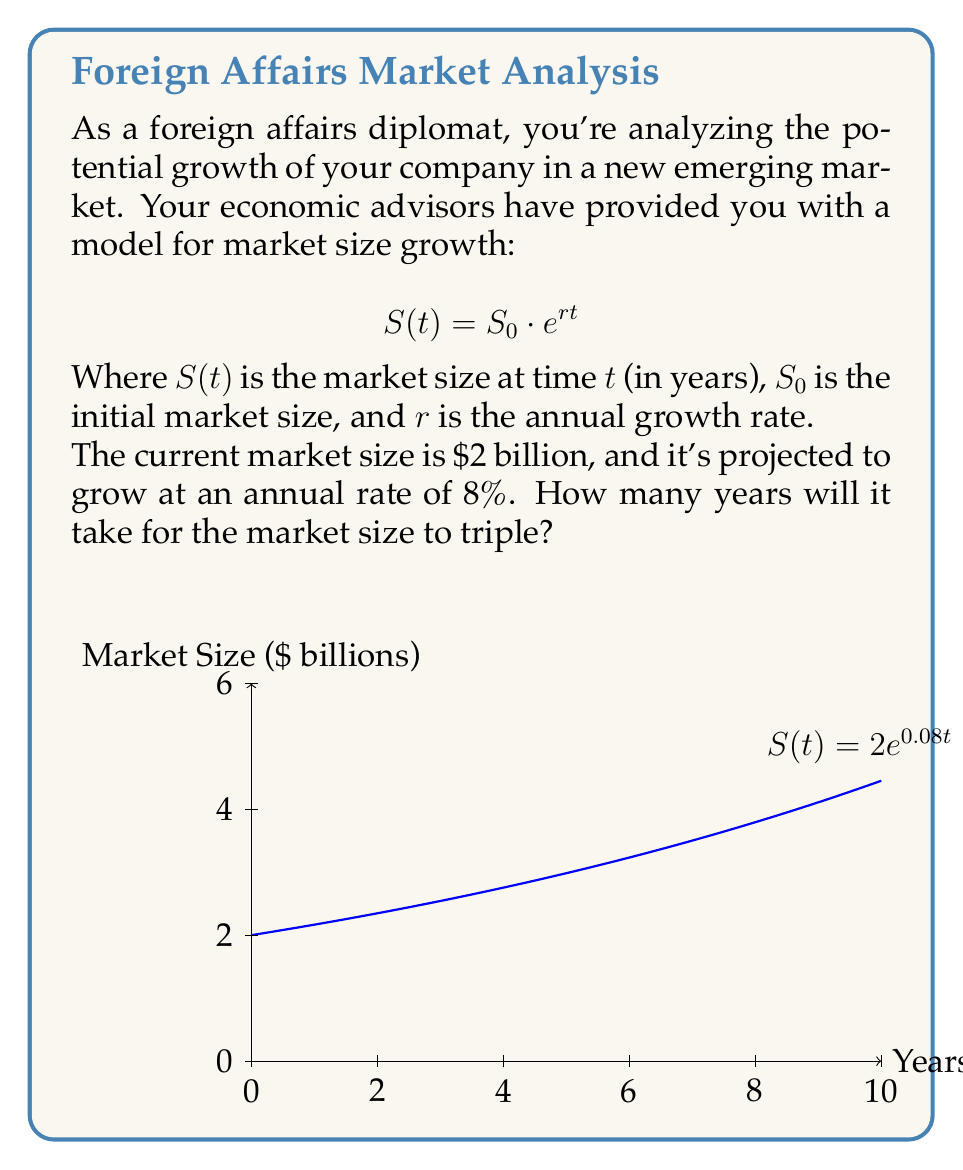Can you answer this question? Let's approach this step-by-step:

1) We're given:
   - Initial market size, $S_0 = \$2$ billion
   - Annual growth rate, $r = 8\% = 0.08$
   - We want to find $t$ when $S(t) = 3S_0 = \$6$ billion

2) We can set up the equation:
   $$6 = 2 \cdot e^{0.08t}$$

3) Divide both sides by 2:
   $$3 = e^{0.08t}$$

4) Take the natural logarithm of both sides:
   $$\ln(3) = \ln(e^{0.08t})$$

5) Simplify the right side using the properties of logarithms:
   $$\ln(3) = 0.08t$$

6) Solve for $t$:
   $$t = \frac{\ln(3)}{0.08}$$

7) Calculate the result:
   $$t \approx 13.86 \text{ years}$$

Since we're dealing with whole years, we round up to 14 years.
Answer: 14 years 